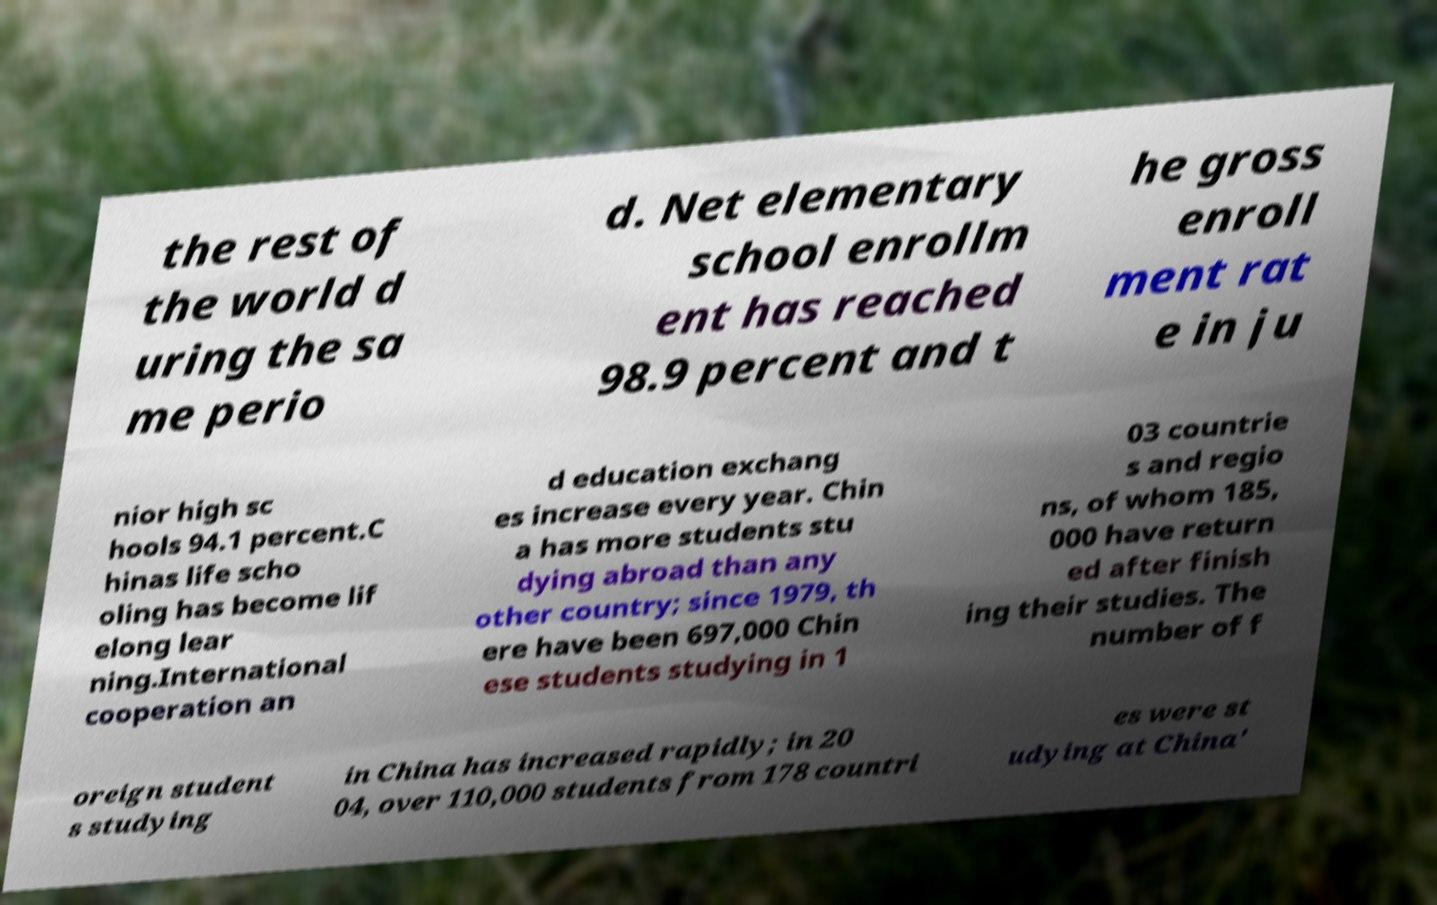What messages or text are displayed in this image? I need them in a readable, typed format. the rest of the world d uring the sa me perio d. Net elementary school enrollm ent has reached 98.9 percent and t he gross enroll ment rat e in ju nior high sc hools 94.1 percent.C hinas life scho oling has become lif elong lear ning.International cooperation an d education exchang es increase every year. Chin a has more students stu dying abroad than any other country; since 1979, th ere have been 697,000 Chin ese students studying in 1 03 countrie s and regio ns, of whom 185, 000 have return ed after finish ing their studies. The number of f oreign student s studying in China has increased rapidly; in 20 04, over 110,000 students from 178 countri es were st udying at China' 